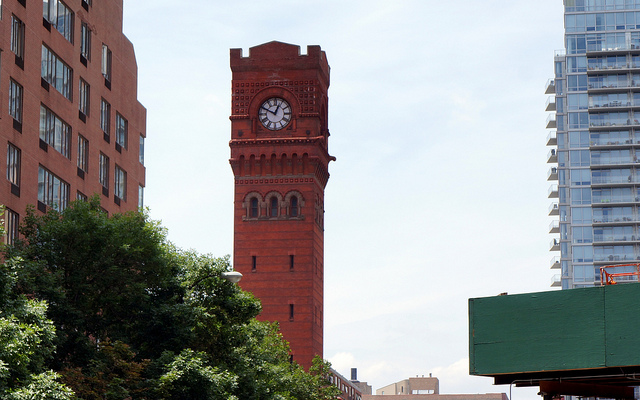Are there any notable features at the top of the tower? Besides the clock, the top of the tower features crenellations that resemble those on medieval castles, adding a decorative and historic element to the structure. 